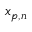<formula> <loc_0><loc_0><loc_500><loc_500>x _ { p , n }</formula> 